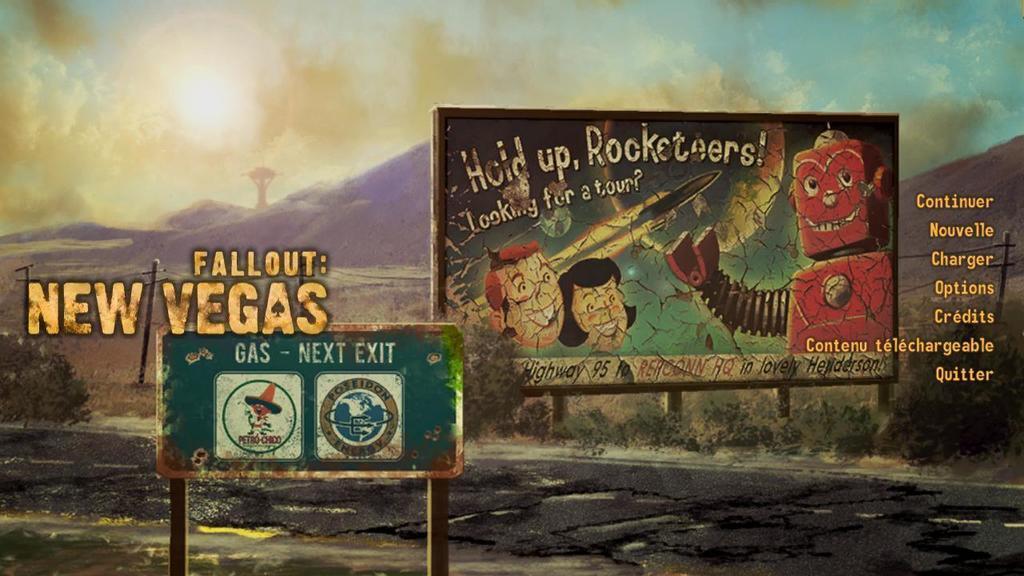How would you summarize this image in a sentence or two? This is a graphic image, there are two ad boards in the front with some anime images and text on it and above its sky and below there are hills. 